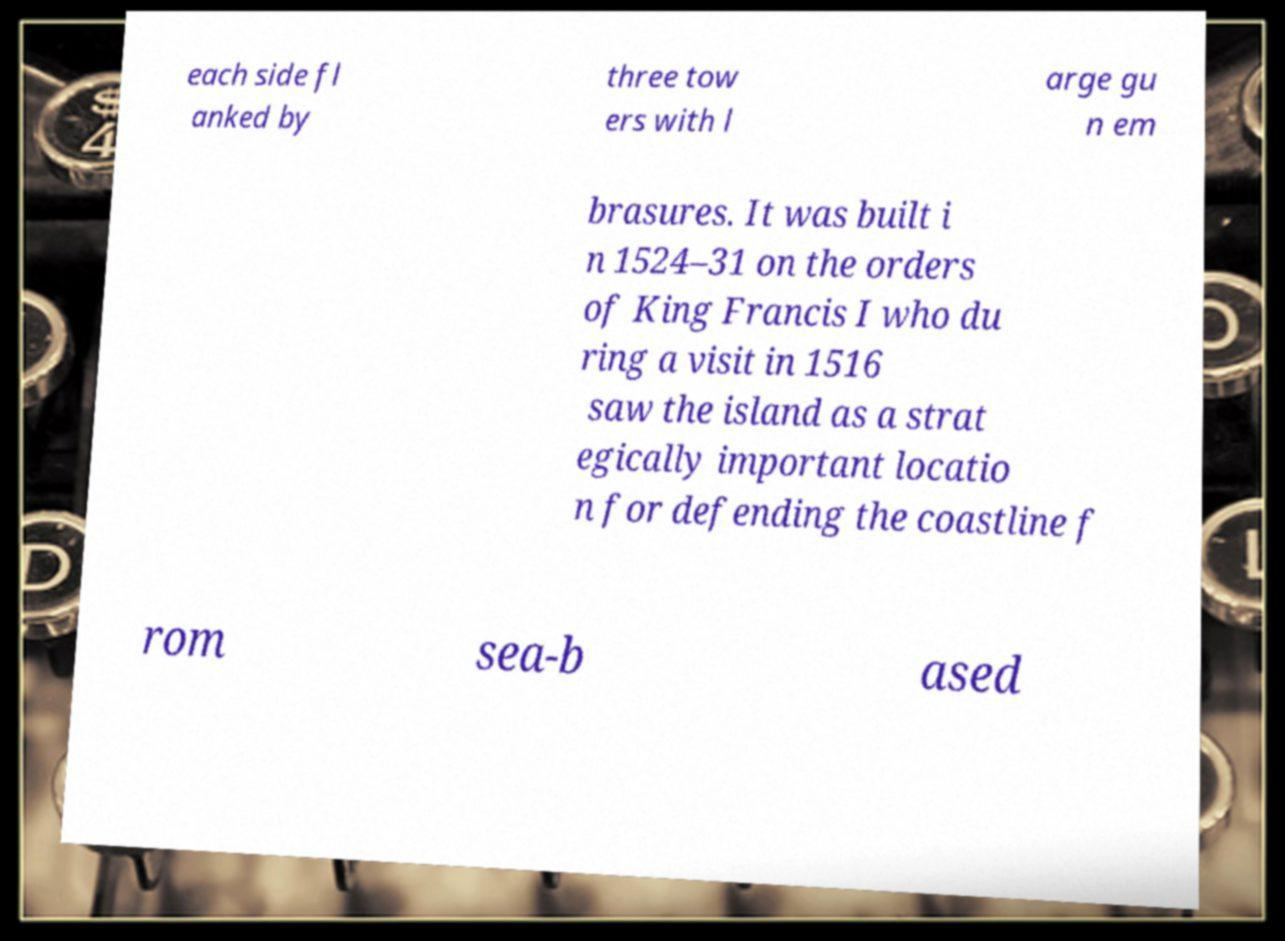Please read and relay the text visible in this image. What does it say? each side fl anked by three tow ers with l arge gu n em brasures. It was built i n 1524–31 on the orders of King Francis I who du ring a visit in 1516 saw the island as a strat egically important locatio n for defending the coastline f rom sea-b ased 